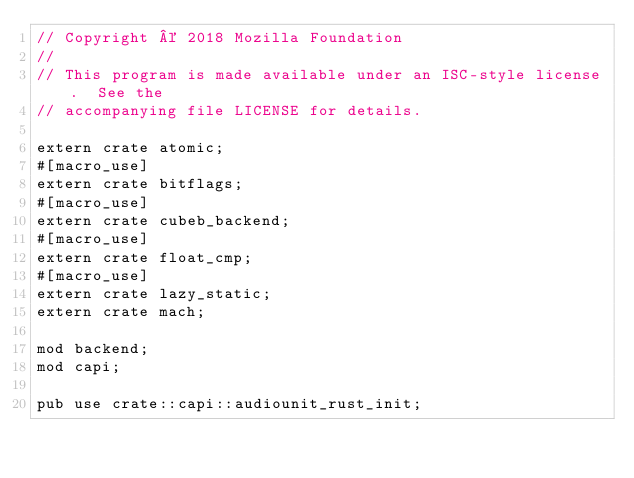Convert code to text. <code><loc_0><loc_0><loc_500><loc_500><_Rust_>// Copyright © 2018 Mozilla Foundation
//
// This program is made available under an ISC-style license.  See the
// accompanying file LICENSE for details.

extern crate atomic;
#[macro_use]
extern crate bitflags;
#[macro_use]
extern crate cubeb_backend;
#[macro_use]
extern crate float_cmp;
#[macro_use]
extern crate lazy_static;
extern crate mach;

mod backend;
mod capi;

pub use crate::capi::audiounit_rust_init;
</code> 